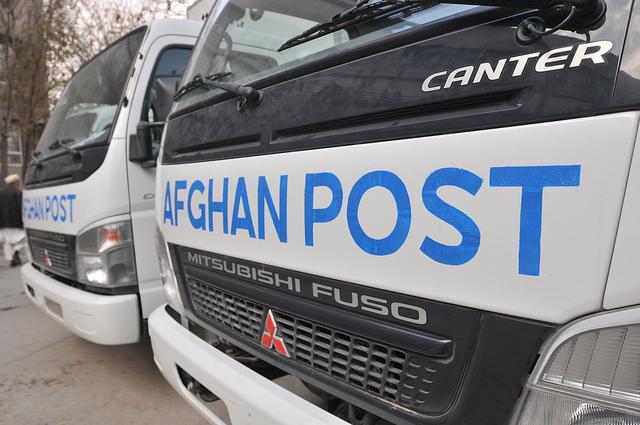How wide is this bus?
Write a very short answer. 8 ft. Are the vehicles parked?
Answer briefly. Yes. What brand vehicle?
Quick response, please. Mitsubishi. 